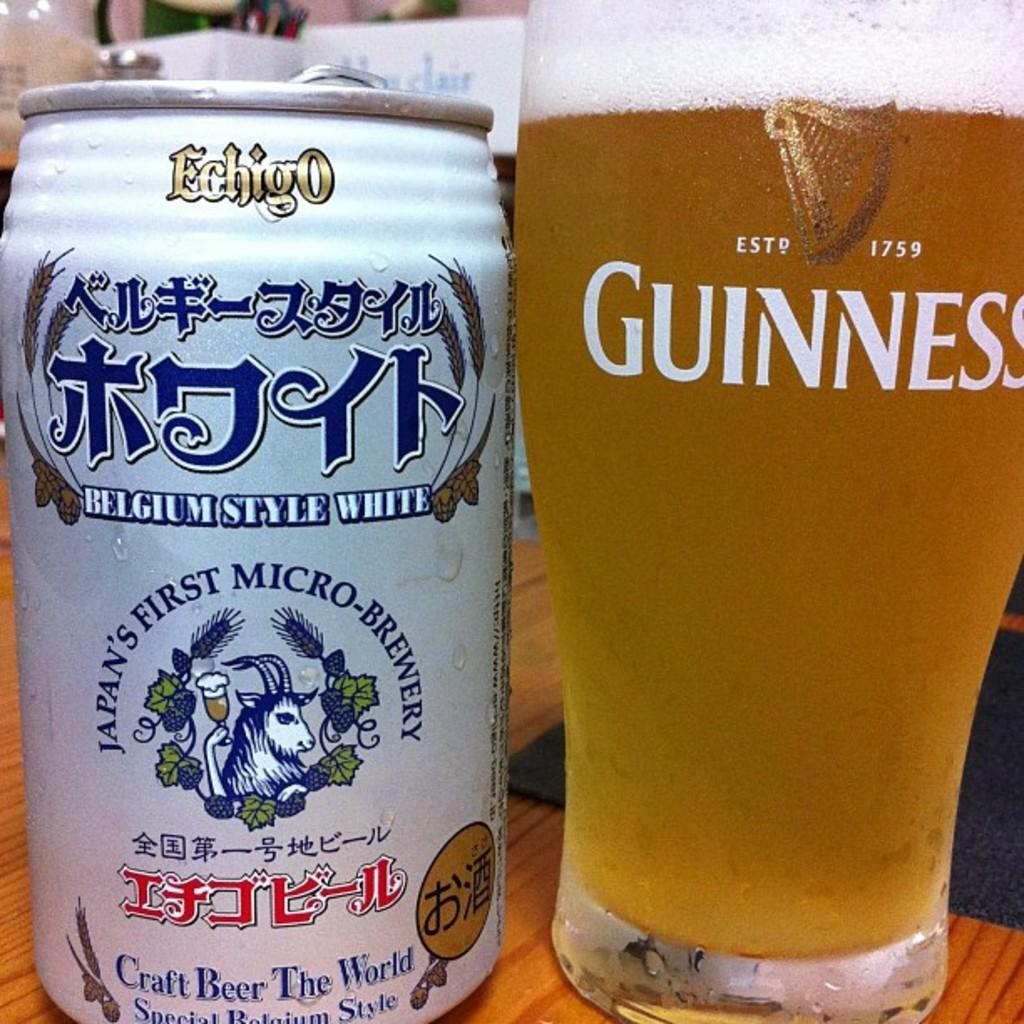Provide a one-sentence caption for the provided image. A glass has Guinness in white letters and the year of 1759. 